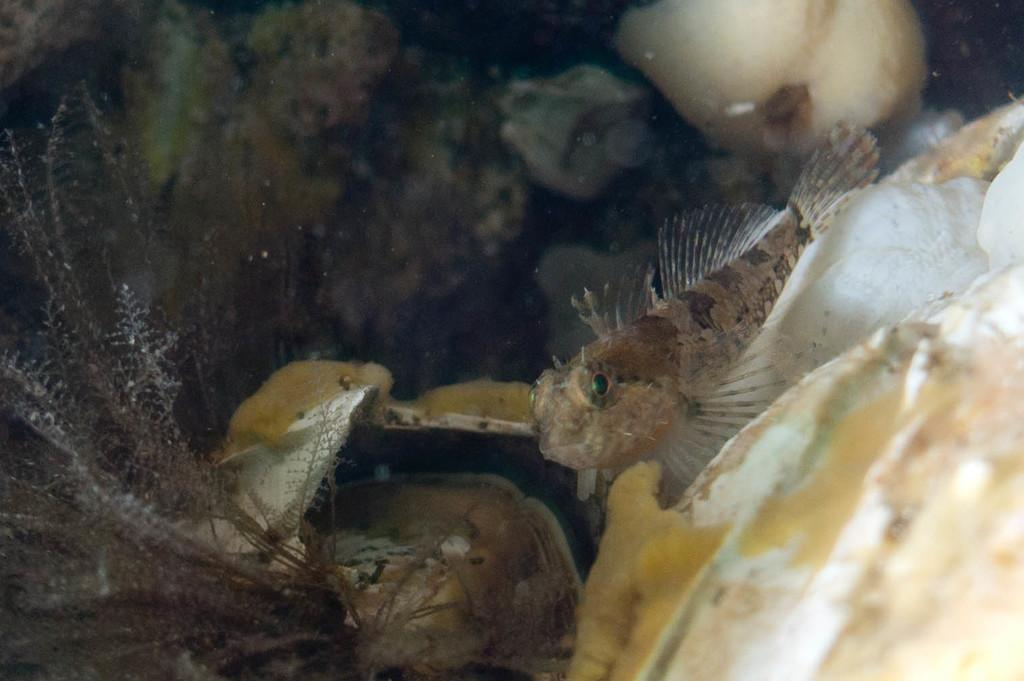What can be found in the front portion of the image? There are shells, fishes, and a plant in the front portion of the image. Can you describe the appearance of the fishes in the image? The fishes are visible in the front portion of the image. What type of vegetation is present in the image? There is a plant in the front portion of the image. How would you describe the background of the image? The background of the image is blurry. What impulse caused the plant to suddenly grow a veil in the image? There is no impulse or veil mentioned in the image; it features shells, fishes, and a plant in the front portion with a blurry background. 